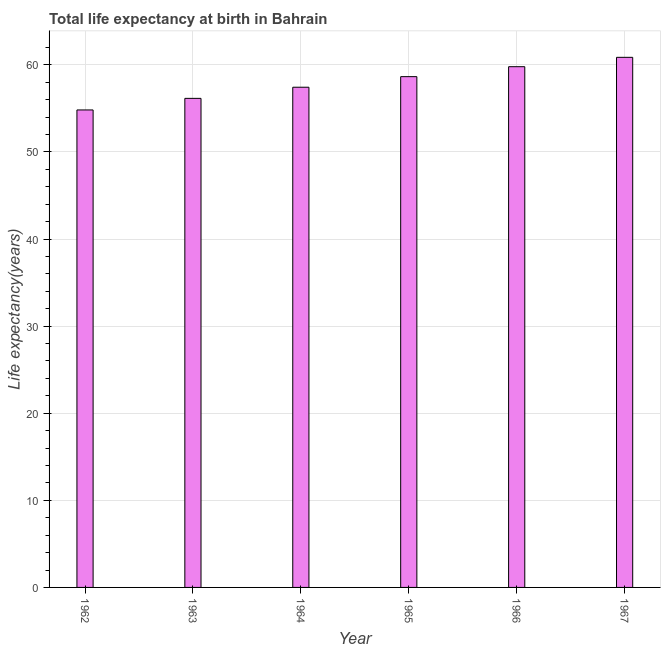What is the title of the graph?
Provide a short and direct response. Total life expectancy at birth in Bahrain. What is the label or title of the X-axis?
Make the answer very short. Year. What is the label or title of the Y-axis?
Keep it short and to the point. Life expectancy(years). What is the life expectancy at birth in 1963?
Make the answer very short. 56.15. Across all years, what is the maximum life expectancy at birth?
Keep it short and to the point. 60.86. Across all years, what is the minimum life expectancy at birth?
Make the answer very short. 54.82. In which year was the life expectancy at birth maximum?
Make the answer very short. 1967. What is the sum of the life expectancy at birth?
Ensure brevity in your answer.  347.67. What is the difference between the life expectancy at birth in 1965 and 1966?
Give a very brief answer. -1.14. What is the average life expectancy at birth per year?
Keep it short and to the point. 57.95. What is the median life expectancy at birth?
Make the answer very short. 58.03. Do a majority of the years between 1967 and 1963 (inclusive) have life expectancy at birth greater than 42 years?
Keep it short and to the point. Yes. Is the life expectancy at birth in 1962 less than that in 1965?
Make the answer very short. Yes. What is the difference between the highest and the second highest life expectancy at birth?
Make the answer very short. 1.07. What is the difference between the highest and the lowest life expectancy at birth?
Offer a very short reply. 6.04. In how many years, is the life expectancy at birth greater than the average life expectancy at birth taken over all years?
Give a very brief answer. 3. What is the Life expectancy(years) in 1962?
Offer a terse response. 54.82. What is the Life expectancy(years) of 1963?
Offer a terse response. 56.15. What is the Life expectancy(years) in 1964?
Make the answer very short. 57.43. What is the Life expectancy(years) in 1965?
Your answer should be very brief. 58.64. What is the Life expectancy(years) in 1966?
Provide a succinct answer. 59.78. What is the Life expectancy(years) of 1967?
Ensure brevity in your answer.  60.86. What is the difference between the Life expectancy(years) in 1962 and 1963?
Ensure brevity in your answer.  -1.33. What is the difference between the Life expectancy(years) in 1962 and 1964?
Your answer should be very brief. -2.61. What is the difference between the Life expectancy(years) in 1962 and 1965?
Give a very brief answer. -3.82. What is the difference between the Life expectancy(years) in 1962 and 1966?
Keep it short and to the point. -4.96. What is the difference between the Life expectancy(years) in 1962 and 1967?
Offer a very short reply. -6.04. What is the difference between the Life expectancy(years) in 1963 and 1964?
Give a very brief answer. -1.28. What is the difference between the Life expectancy(years) in 1963 and 1965?
Provide a short and direct response. -2.49. What is the difference between the Life expectancy(years) in 1963 and 1966?
Give a very brief answer. -3.64. What is the difference between the Life expectancy(years) in 1963 and 1967?
Your response must be concise. -4.71. What is the difference between the Life expectancy(years) in 1964 and 1965?
Provide a short and direct response. -1.21. What is the difference between the Life expectancy(years) in 1964 and 1966?
Offer a terse response. -2.36. What is the difference between the Life expectancy(years) in 1964 and 1967?
Your response must be concise. -3.43. What is the difference between the Life expectancy(years) in 1965 and 1966?
Your answer should be compact. -1.14. What is the difference between the Life expectancy(years) in 1965 and 1967?
Offer a terse response. -2.22. What is the difference between the Life expectancy(years) in 1966 and 1967?
Keep it short and to the point. -1.07. What is the ratio of the Life expectancy(years) in 1962 to that in 1963?
Provide a short and direct response. 0.98. What is the ratio of the Life expectancy(years) in 1962 to that in 1964?
Offer a very short reply. 0.95. What is the ratio of the Life expectancy(years) in 1962 to that in 1965?
Give a very brief answer. 0.94. What is the ratio of the Life expectancy(years) in 1962 to that in 1966?
Offer a very short reply. 0.92. What is the ratio of the Life expectancy(years) in 1962 to that in 1967?
Your response must be concise. 0.9. What is the ratio of the Life expectancy(years) in 1963 to that in 1966?
Offer a very short reply. 0.94. What is the ratio of the Life expectancy(years) in 1963 to that in 1967?
Your response must be concise. 0.92. What is the ratio of the Life expectancy(years) in 1964 to that in 1965?
Your response must be concise. 0.98. What is the ratio of the Life expectancy(years) in 1964 to that in 1966?
Provide a short and direct response. 0.96. What is the ratio of the Life expectancy(years) in 1964 to that in 1967?
Give a very brief answer. 0.94. What is the ratio of the Life expectancy(years) in 1965 to that in 1966?
Offer a terse response. 0.98. What is the ratio of the Life expectancy(years) in 1965 to that in 1967?
Your answer should be very brief. 0.96. What is the ratio of the Life expectancy(years) in 1966 to that in 1967?
Your response must be concise. 0.98. 